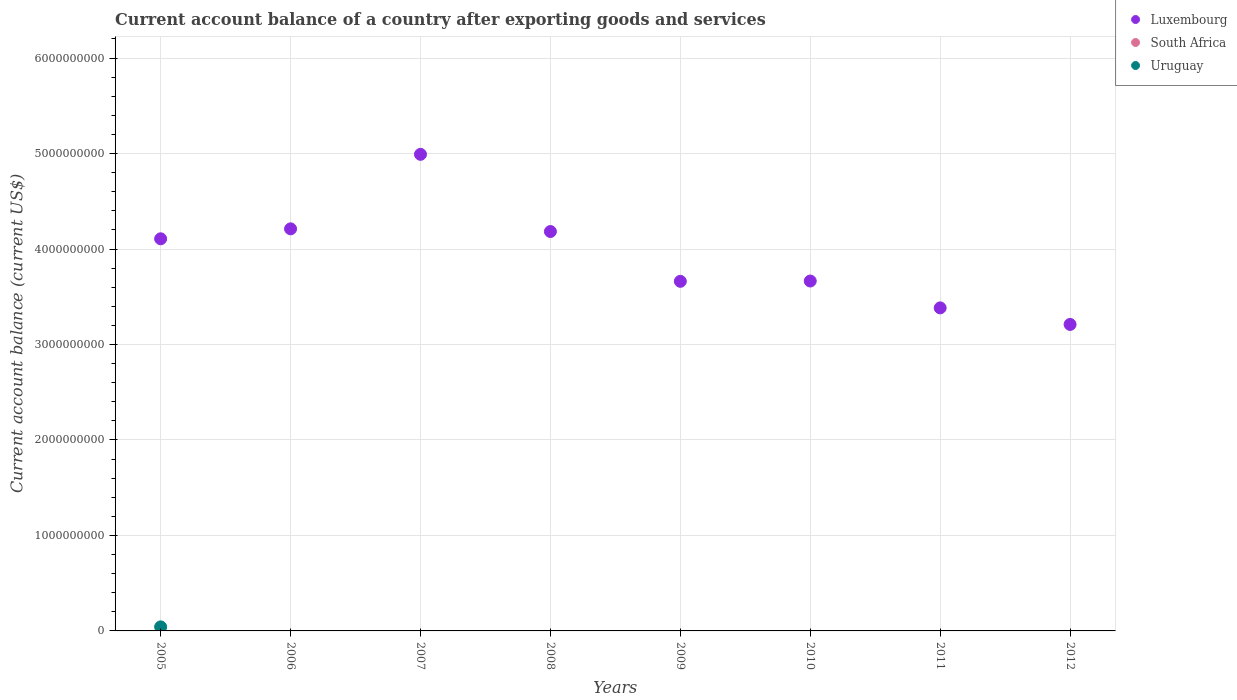How many different coloured dotlines are there?
Keep it short and to the point. 2. Across all years, what is the maximum account balance in Luxembourg?
Your answer should be compact. 4.99e+09. Across all years, what is the minimum account balance in Luxembourg?
Your answer should be compact. 3.21e+09. In which year was the account balance in Luxembourg maximum?
Provide a succinct answer. 2007. What is the total account balance in Uruguay in the graph?
Provide a short and direct response. 4.23e+07. What is the difference between the account balance in Luxembourg in 2006 and that in 2008?
Your answer should be very brief. 2.81e+07. What is the difference between the account balance in South Africa in 2005 and the account balance in Uruguay in 2007?
Your response must be concise. 0. What is the average account balance in Uruguay per year?
Provide a succinct answer. 5.28e+06. What is the ratio of the account balance in Luxembourg in 2005 to that in 2006?
Offer a terse response. 0.98. What is the difference between the highest and the second highest account balance in Luxembourg?
Provide a short and direct response. 7.80e+08. What is the difference between the highest and the lowest account balance in Uruguay?
Give a very brief answer. 4.23e+07. Is the sum of the account balance in Luxembourg in 2011 and 2012 greater than the maximum account balance in South Africa across all years?
Make the answer very short. Yes. Does the account balance in South Africa monotonically increase over the years?
Make the answer very short. No. Is the account balance in Luxembourg strictly less than the account balance in Uruguay over the years?
Ensure brevity in your answer.  No. How many years are there in the graph?
Your response must be concise. 8. Are the values on the major ticks of Y-axis written in scientific E-notation?
Keep it short and to the point. No. Where does the legend appear in the graph?
Keep it short and to the point. Top right. What is the title of the graph?
Offer a terse response. Current account balance of a country after exporting goods and services. Does "Malawi" appear as one of the legend labels in the graph?
Provide a succinct answer. No. What is the label or title of the Y-axis?
Your response must be concise. Current account balance (current US$). What is the Current account balance (current US$) in Luxembourg in 2005?
Provide a succinct answer. 4.11e+09. What is the Current account balance (current US$) in South Africa in 2005?
Make the answer very short. 0. What is the Current account balance (current US$) in Uruguay in 2005?
Provide a short and direct response. 4.23e+07. What is the Current account balance (current US$) of Luxembourg in 2006?
Offer a terse response. 4.21e+09. What is the Current account balance (current US$) of South Africa in 2006?
Your response must be concise. 0. What is the Current account balance (current US$) in Luxembourg in 2007?
Your answer should be compact. 4.99e+09. What is the Current account balance (current US$) of Uruguay in 2007?
Your answer should be compact. 0. What is the Current account balance (current US$) in Luxembourg in 2008?
Offer a very short reply. 4.18e+09. What is the Current account balance (current US$) of Luxembourg in 2009?
Make the answer very short. 3.66e+09. What is the Current account balance (current US$) of South Africa in 2009?
Give a very brief answer. 0. What is the Current account balance (current US$) in Luxembourg in 2010?
Your answer should be very brief. 3.66e+09. What is the Current account balance (current US$) of South Africa in 2010?
Your answer should be very brief. 0. What is the Current account balance (current US$) of Luxembourg in 2011?
Your answer should be very brief. 3.38e+09. What is the Current account balance (current US$) in Uruguay in 2011?
Your answer should be very brief. 0. What is the Current account balance (current US$) of Luxembourg in 2012?
Give a very brief answer. 3.21e+09. Across all years, what is the maximum Current account balance (current US$) in Luxembourg?
Ensure brevity in your answer.  4.99e+09. Across all years, what is the maximum Current account balance (current US$) of Uruguay?
Offer a terse response. 4.23e+07. Across all years, what is the minimum Current account balance (current US$) in Luxembourg?
Keep it short and to the point. 3.21e+09. What is the total Current account balance (current US$) of Luxembourg in the graph?
Give a very brief answer. 3.14e+1. What is the total Current account balance (current US$) of South Africa in the graph?
Your response must be concise. 0. What is the total Current account balance (current US$) of Uruguay in the graph?
Your response must be concise. 4.23e+07. What is the difference between the Current account balance (current US$) of Luxembourg in 2005 and that in 2006?
Offer a terse response. -1.04e+08. What is the difference between the Current account balance (current US$) of Luxembourg in 2005 and that in 2007?
Provide a short and direct response. -8.85e+08. What is the difference between the Current account balance (current US$) in Luxembourg in 2005 and that in 2008?
Your answer should be compact. -7.62e+07. What is the difference between the Current account balance (current US$) of Luxembourg in 2005 and that in 2009?
Offer a terse response. 4.45e+08. What is the difference between the Current account balance (current US$) in Luxembourg in 2005 and that in 2010?
Keep it short and to the point. 4.42e+08. What is the difference between the Current account balance (current US$) in Luxembourg in 2005 and that in 2011?
Provide a succinct answer. 7.23e+08. What is the difference between the Current account balance (current US$) of Luxembourg in 2005 and that in 2012?
Give a very brief answer. 8.97e+08. What is the difference between the Current account balance (current US$) of Luxembourg in 2006 and that in 2007?
Give a very brief answer. -7.80e+08. What is the difference between the Current account balance (current US$) of Luxembourg in 2006 and that in 2008?
Your answer should be very brief. 2.81e+07. What is the difference between the Current account balance (current US$) in Luxembourg in 2006 and that in 2009?
Ensure brevity in your answer.  5.50e+08. What is the difference between the Current account balance (current US$) of Luxembourg in 2006 and that in 2010?
Make the answer very short. 5.47e+08. What is the difference between the Current account balance (current US$) of Luxembourg in 2006 and that in 2011?
Provide a succinct answer. 8.28e+08. What is the difference between the Current account balance (current US$) in Luxembourg in 2006 and that in 2012?
Your answer should be very brief. 1.00e+09. What is the difference between the Current account balance (current US$) in Luxembourg in 2007 and that in 2008?
Make the answer very short. 8.08e+08. What is the difference between the Current account balance (current US$) in Luxembourg in 2007 and that in 2009?
Your answer should be very brief. 1.33e+09. What is the difference between the Current account balance (current US$) of Luxembourg in 2007 and that in 2010?
Offer a very short reply. 1.33e+09. What is the difference between the Current account balance (current US$) of Luxembourg in 2007 and that in 2011?
Give a very brief answer. 1.61e+09. What is the difference between the Current account balance (current US$) in Luxembourg in 2007 and that in 2012?
Offer a terse response. 1.78e+09. What is the difference between the Current account balance (current US$) in Luxembourg in 2008 and that in 2009?
Keep it short and to the point. 5.22e+08. What is the difference between the Current account balance (current US$) in Luxembourg in 2008 and that in 2010?
Make the answer very short. 5.18e+08. What is the difference between the Current account balance (current US$) in Luxembourg in 2008 and that in 2011?
Give a very brief answer. 8.00e+08. What is the difference between the Current account balance (current US$) in Luxembourg in 2008 and that in 2012?
Offer a terse response. 9.73e+08. What is the difference between the Current account balance (current US$) of Luxembourg in 2009 and that in 2010?
Provide a succinct answer. -3.17e+06. What is the difference between the Current account balance (current US$) of Luxembourg in 2009 and that in 2011?
Keep it short and to the point. 2.78e+08. What is the difference between the Current account balance (current US$) in Luxembourg in 2009 and that in 2012?
Provide a short and direct response. 4.51e+08. What is the difference between the Current account balance (current US$) of Luxembourg in 2010 and that in 2011?
Provide a short and direct response. 2.81e+08. What is the difference between the Current account balance (current US$) of Luxembourg in 2010 and that in 2012?
Keep it short and to the point. 4.55e+08. What is the difference between the Current account balance (current US$) of Luxembourg in 2011 and that in 2012?
Ensure brevity in your answer.  1.73e+08. What is the average Current account balance (current US$) of Luxembourg per year?
Give a very brief answer. 3.93e+09. What is the average Current account balance (current US$) of Uruguay per year?
Provide a short and direct response. 5.28e+06. In the year 2005, what is the difference between the Current account balance (current US$) of Luxembourg and Current account balance (current US$) of Uruguay?
Your answer should be compact. 4.06e+09. What is the ratio of the Current account balance (current US$) in Luxembourg in 2005 to that in 2006?
Your response must be concise. 0.98. What is the ratio of the Current account balance (current US$) of Luxembourg in 2005 to that in 2007?
Provide a short and direct response. 0.82. What is the ratio of the Current account balance (current US$) in Luxembourg in 2005 to that in 2008?
Provide a succinct answer. 0.98. What is the ratio of the Current account balance (current US$) of Luxembourg in 2005 to that in 2009?
Provide a succinct answer. 1.12. What is the ratio of the Current account balance (current US$) of Luxembourg in 2005 to that in 2010?
Keep it short and to the point. 1.12. What is the ratio of the Current account balance (current US$) in Luxembourg in 2005 to that in 2011?
Provide a short and direct response. 1.21. What is the ratio of the Current account balance (current US$) in Luxembourg in 2005 to that in 2012?
Ensure brevity in your answer.  1.28. What is the ratio of the Current account balance (current US$) of Luxembourg in 2006 to that in 2007?
Give a very brief answer. 0.84. What is the ratio of the Current account balance (current US$) of Luxembourg in 2006 to that in 2008?
Offer a terse response. 1.01. What is the ratio of the Current account balance (current US$) in Luxembourg in 2006 to that in 2009?
Keep it short and to the point. 1.15. What is the ratio of the Current account balance (current US$) of Luxembourg in 2006 to that in 2010?
Give a very brief answer. 1.15. What is the ratio of the Current account balance (current US$) of Luxembourg in 2006 to that in 2011?
Offer a terse response. 1.24. What is the ratio of the Current account balance (current US$) of Luxembourg in 2006 to that in 2012?
Offer a terse response. 1.31. What is the ratio of the Current account balance (current US$) in Luxembourg in 2007 to that in 2008?
Make the answer very short. 1.19. What is the ratio of the Current account balance (current US$) of Luxembourg in 2007 to that in 2009?
Offer a terse response. 1.36. What is the ratio of the Current account balance (current US$) in Luxembourg in 2007 to that in 2010?
Provide a succinct answer. 1.36. What is the ratio of the Current account balance (current US$) of Luxembourg in 2007 to that in 2011?
Your answer should be very brief. 1.48. What is the ratio of the Current account balance (current US$) in Luxembourg in 2007 to that in 2012?
Provide a short and direct response. 1.55. What is the ratio of the Current account balance (current US$) of Luxembourg in 2008 to that in 2009?
Offer a very short reply. 1.14. What is the ratio of the Current account balance (current US$) of Luxembourg in 2008 to that in 2010?
Provide a short and direct response. 1.14. What is the ratio of the Current account balance (current US$) of Luxembourg in 2008 to that in 2011?
Provide a succinct answer. 1.24. What is the ratio of the Current account balance (current US$) in Luxembourg in 2008 to that in 2012?
Offer a terse response. 1.3. What is the ratio of the Current account balance (current US$) of Luxembourg in 2009 to that in 2011?
Keep it short and to the point. 1.08. What is the ratio of the Current account balance (current US$) in Luxembourg in 2009 to that in 2012?
Keep it short and to the point. 1.14. What is the ratio of the Current account balance (current US$) of Luxembourg in 2010 to that in 2011?
Keep it short and to the point. 1.08. What is the ratio of the Current account balance (current US$) in Luxembourg in 2010 to that in 2012?
Provide a succinct answer. 1.14. What is the ratio of the Current account balance (current US$) of Luxembourg in 2011 to that in 2012?
Offer a terse response. 1.05. What is the difference between the highest and the second highest Current account balance (current US$) in Luxembourg?
Make the answer very short. 7.80e+08. What is the difference between the highest and the lowest Current account balance (current US$) in Luxembourg?
Your answer should be very brief. 1.78e+09. What is the difference between the highest and the lowest Current account balance (current US$) of Uruguay?
Make the answer very short. 4.23e+07. 